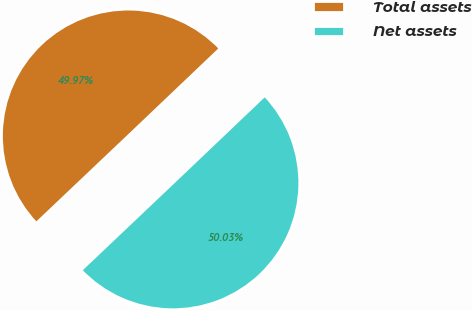<chart> <loc_0><loc_0><loc_500><loc_500><pie_chart><fcel>Total assets<fcel>Net assets<nl><fcel>49.97%<fcel>50.03%<nl></chart> 